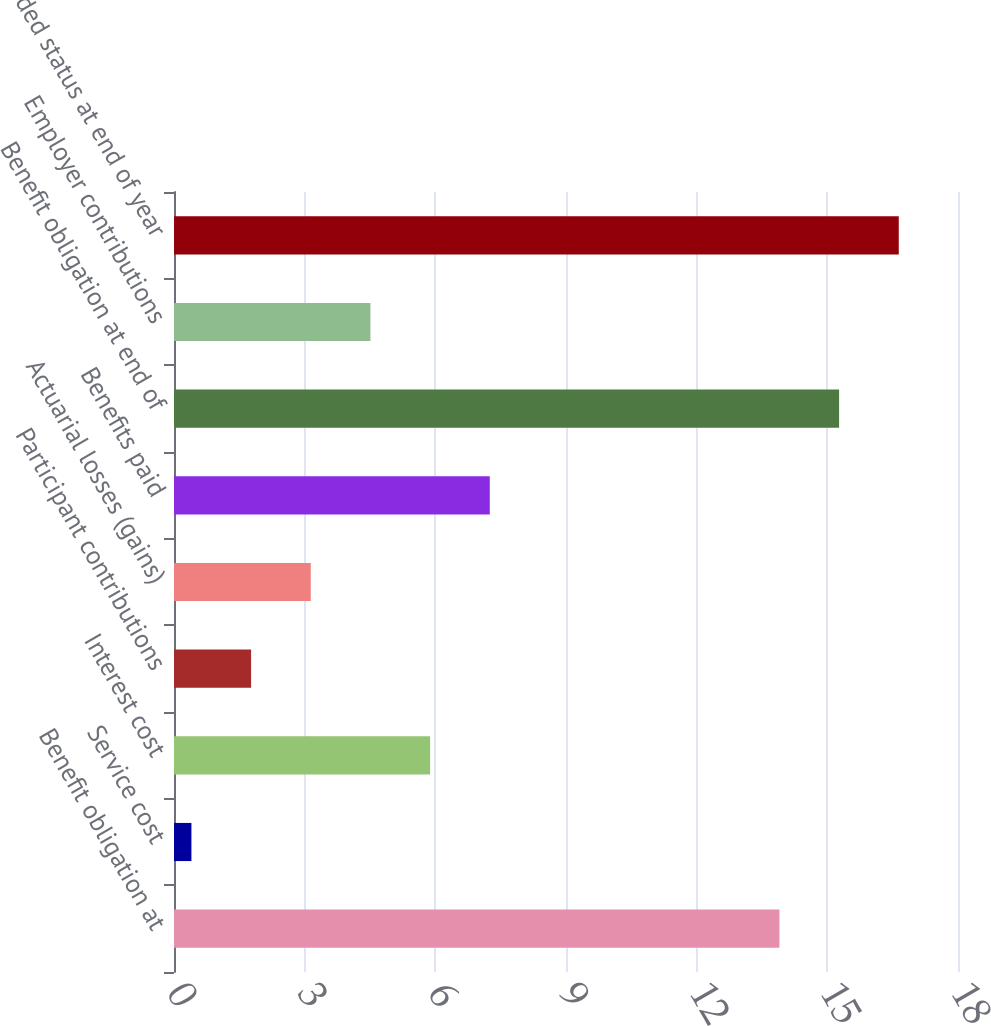<chart> <loc_0><loc_0><loc_500><loc_500><bar_chart><fcel>Benefit obligation at<fcel>Service cost<fcel>Interest cost<fcel>Participant contributions<fcel>Actuarial losses (gains)<fcel>Benefits paid<fcel>Benefit obligation at end of<fcel>Employer contributions<fcel>Funded status at end of year<nl><fcel>13.9<fcel>0.4<fcel>5.88<fcel>1.77<fcel>3.14<fcel>7.25<fcel>15.27<fcel>4.51<fcel>16.64<nl></chart> 